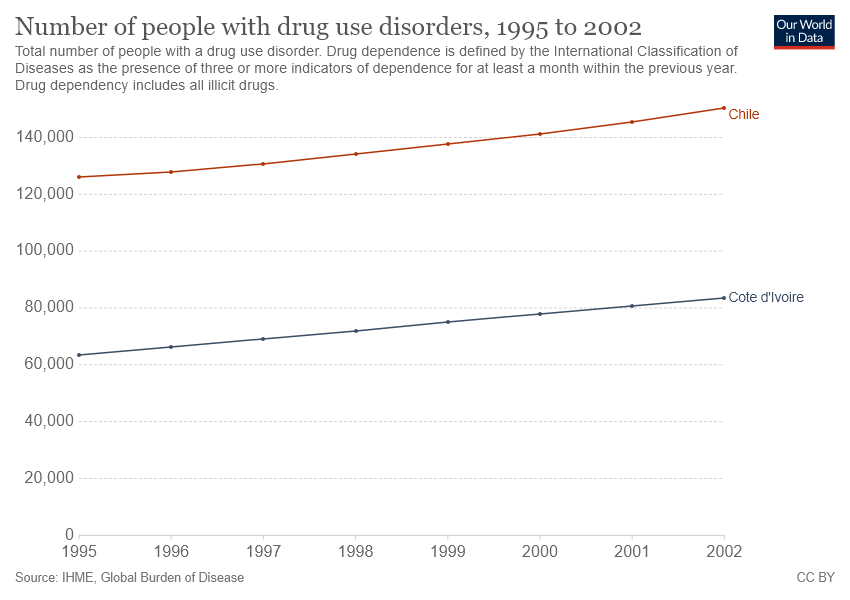Identify some key points in this picture. The number of individuals with drug use disorders in Chile from 1995 to 2002 was not consistently between 120,000 and 140,000, as there were instances when the number was higher or lower than this range. The line representing Chile is always above the line representing Cote d'Ivoire. 